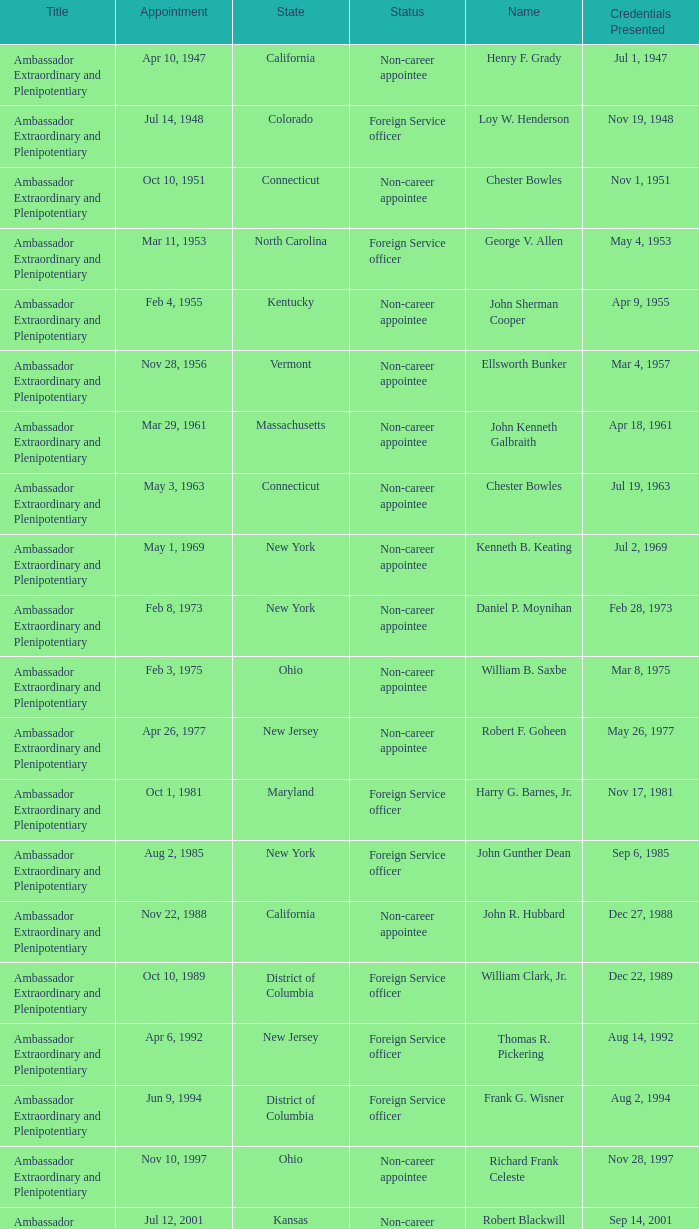What is the title for david campbell mulford? Ambassador Extraordinary and Plenipotentiary. 